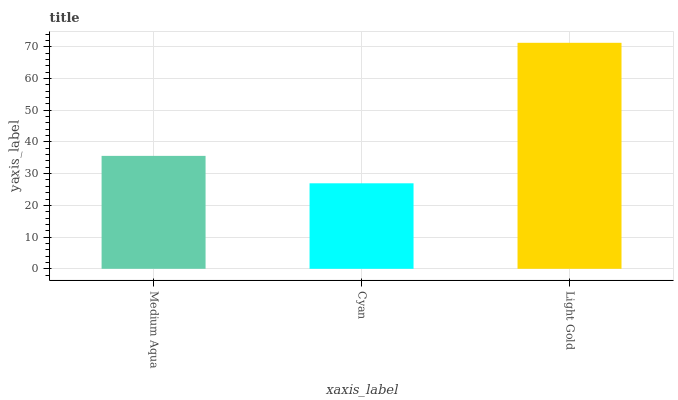Is Cyan the minimum?
Answer yes or no. Yes. Is Light Gold the maximum?
Answer yes or no. Yes. Is Light Gold the minimum?
Answer yes or no. No. Is Cyan the maximum?
Answer yes or no. No. Is Light Gold greater than Cyan?
Answer yes or no. Yes. Is Cyan less than Light Gold?
Answer yes or no. Yes. Is Cyan greater than Light Gold?
Answer yes or no. No. Is Light Gold less than Cyan?
Answer yes or no. No. Is Medium Aqua the high median?
Answer yes or no. Yes. Is Medium Aqua the low median?
Answer yes or no. Yes. Is Light Gold the high median?
Answer yes or no. No. Is Cyan the low median?
Answer yes or no. No. 